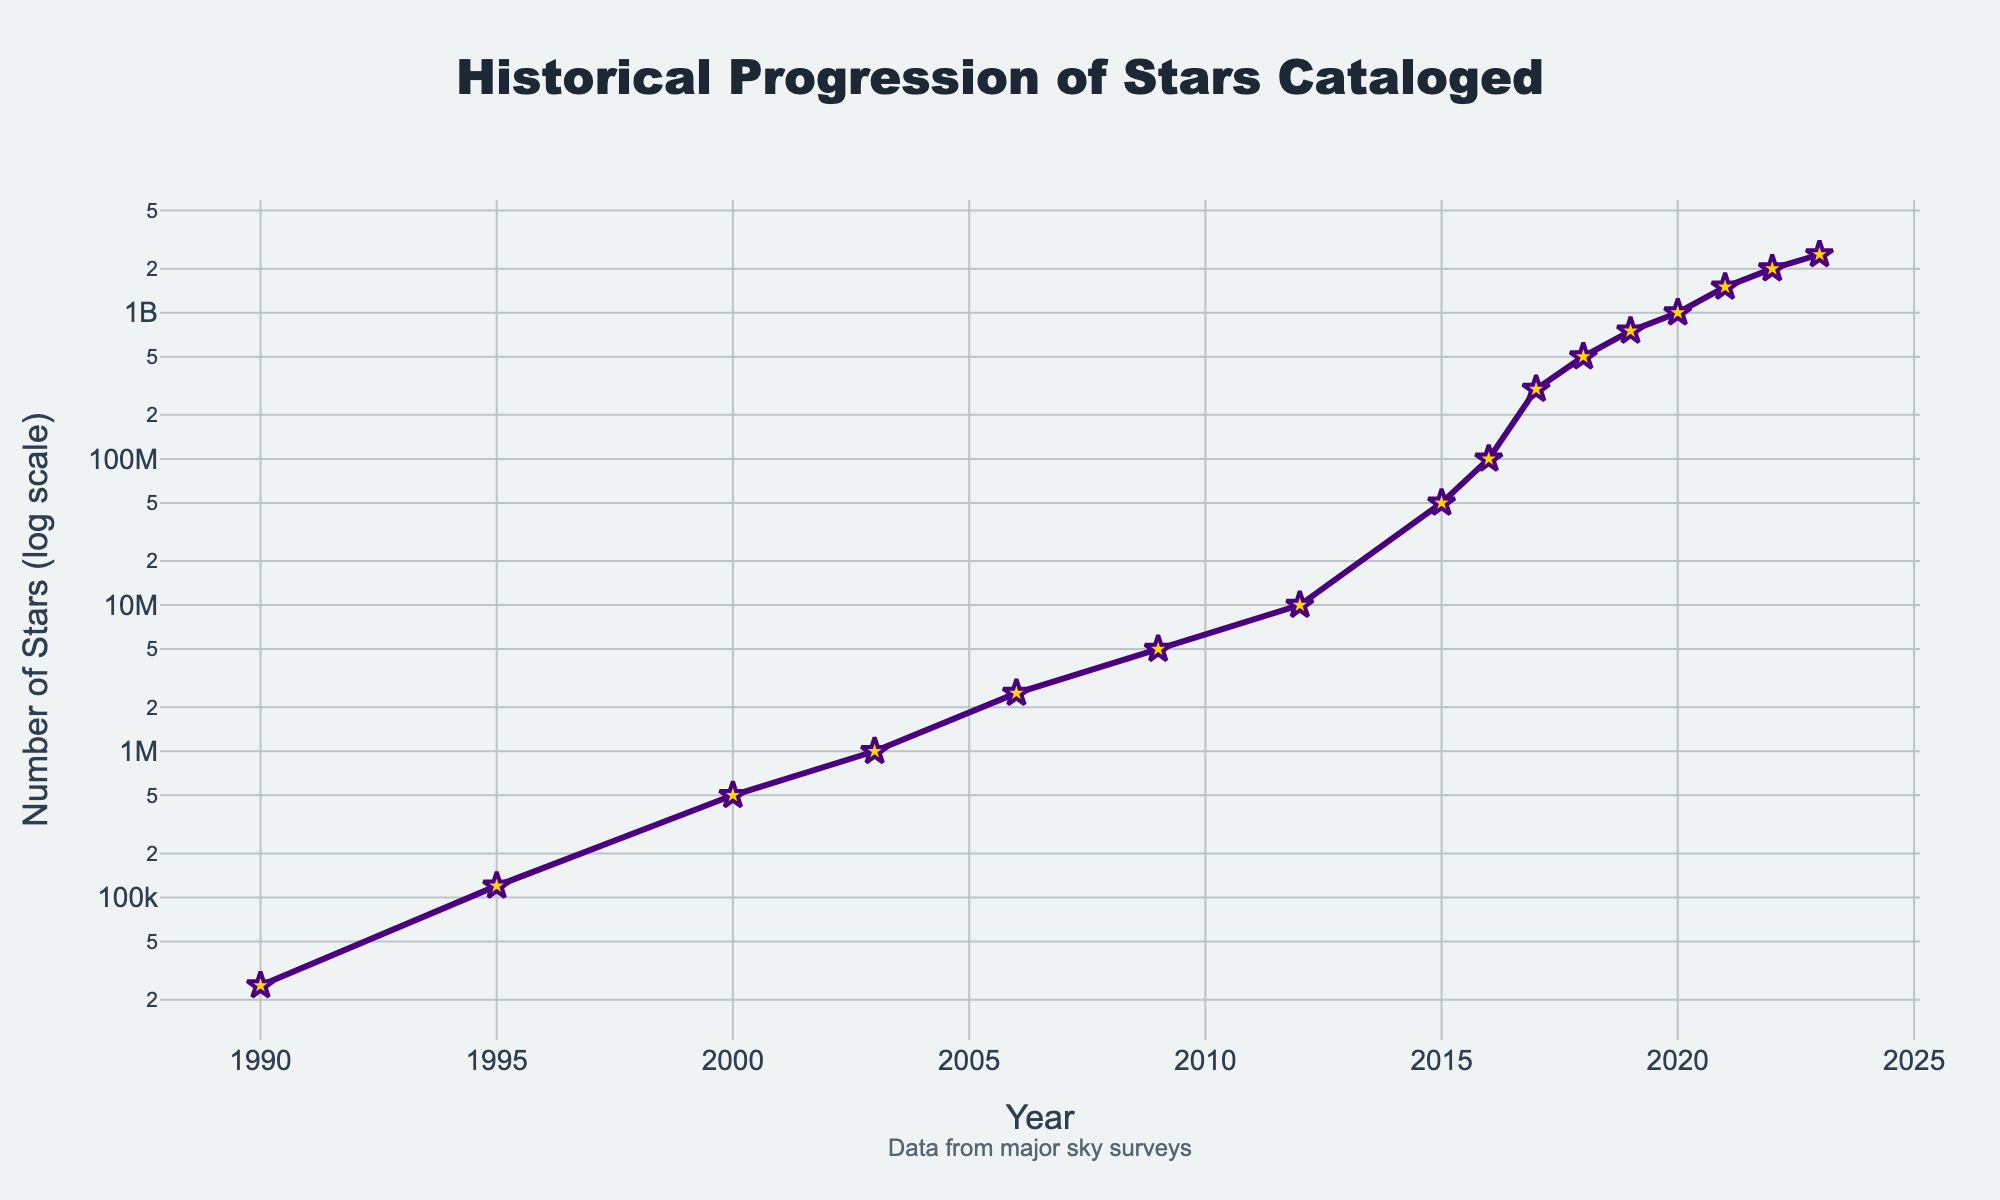What year did the number of stars cataloged first reach 1 billion? The line chart shows the historical progression of stars cataloged. Looking at the y-axis markers, 1 billion stars were first cataloged in the year where "1,000,000,000" aligns with the 2020 mark on the x-axis.
Answer: 2020 What is the rate of increase in the number of stars cataloged between 2015 and 2016? In 2015, the number of stars cataloged was 50 million, and in 2016, it was 100 million. The difference is 50 million, and it occurred over one year. Hence, the rate of increase is 50 million per year.
Answer: 50 million per year During which period was the growth rate of stars cataloged the fastest? From the figure, the period with the steepest upward slope indicates the fastest growth. The segment between 2019 and 2021 shows the sharpest increase, rising from 750 million to 1.5 billion stars cataloged.
Answer: 2019-2021 By how much did the number of stars cataloged increase between 2009 and 2015? In 2009, there were 5 million stars cataloged, and by 2015, it reached 50 million. The increase is calculated by subtracting these values: 50 million - 5 million = 45 million.
Answer: 45 million Which year saw the number of stars cataloged double for the last time according to the chart? The number of stars cataloged doubled from 1 billion in 2020 to 2 billion in 2022. This is noted by checking where the number of stars aligns with the 2 billion marker on the y-axis and the 2022 marker on the x-axis.
Answer: 2022 What is the approximate average yearly increase in the number of stars cataloged from 1990 to 2023? To find the average annual increase:
1. Calculate the total increase in stars cataloged between 1990 (25,000) and 2023 (2.5 billion): 2,500,000,000 - 25,000 = 2,499,975,000.
2. Divide this difference by the number of years between 1990 and 2023 (33 years): 2,499,975,000 / 33 ≈ 75,757,575 stars per year.
Answer: ~75.8 million stars per year Between which consecutive years did the number of stars cataloged increase by 200 million? The figure shows that between 2017 (300 million) and 2018 (500 million), the number of stars cataloged increased by 200 million.
Answer: 2017-2018 What is the log-scale y-axis indicating in terms of trends in the data? The log-scale y-axis indicates exponential growth in the number of stars cataloged over time. This can be seen as the data points form a mostly straight line in the log scale, suggesting a consistent multiplicative rate of increase.
Answer: Exponential growth How many times greater is the number of stars cataloged in 2023 compared to 1990? In 2023, there were 2.5 billion stars cataloged, and in 1990, there were 25,000. Dividing these gives: 2,500,000,000 / 25,000 = 100,000 times greater.
Answer: 100,000 times What visual element indicates the number of stars cataloged at each data point? The stars cataloged at each data point are represented by markers in the shape of stars, which stand out against the plot's color scheme.
Answer: Star-shaped markers 